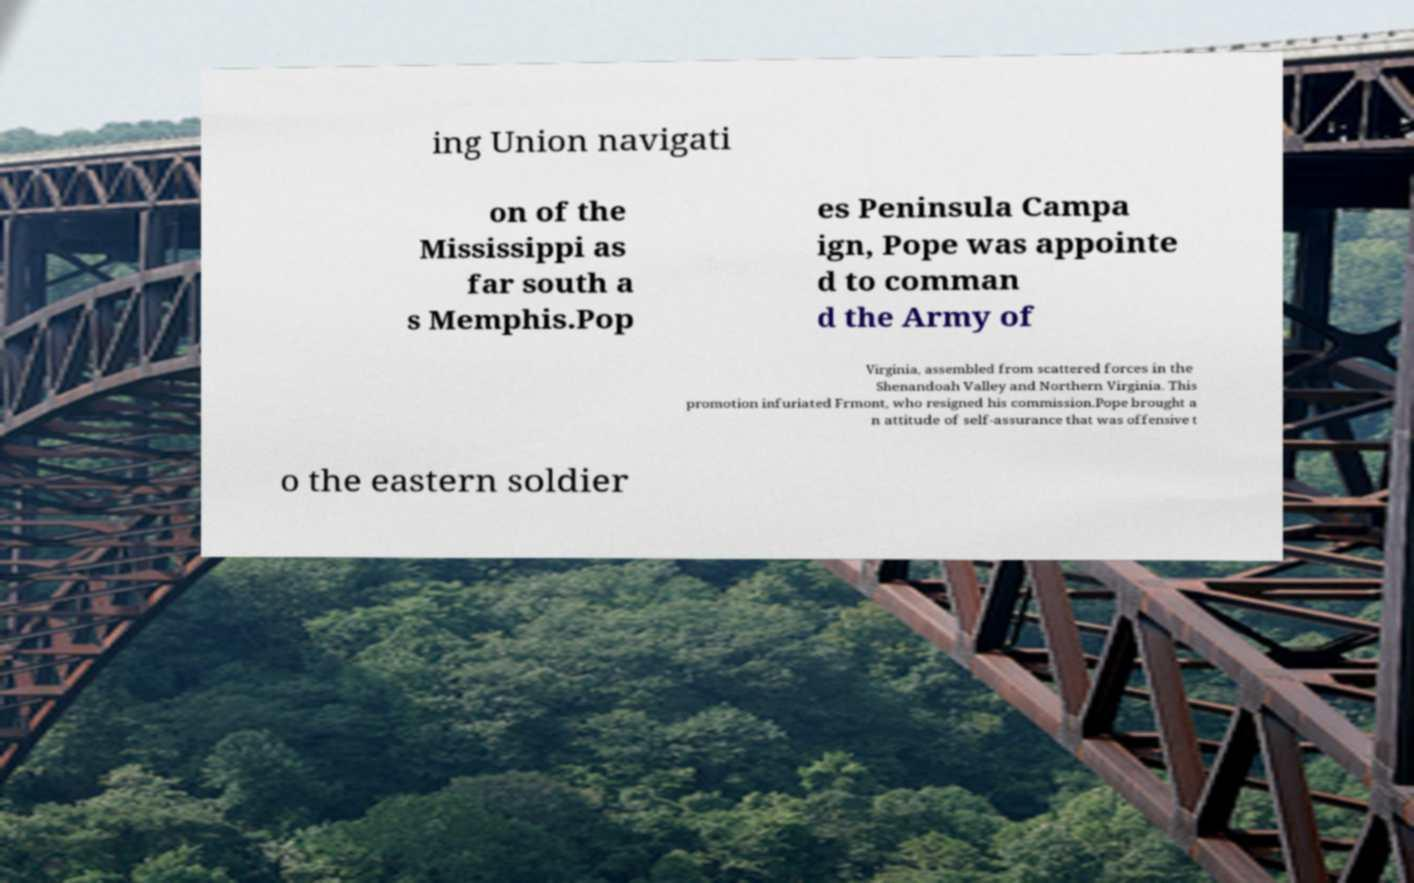What messages or text are displayed in this image? I need them in a readable, typed format. ing Union navigati on of the Mississippi as far south a s Memphis.Pop es Peninsula Campa ign, Pope was appointe d to comman d the Army of Virginia, assembled from scattered forces in the Shenandoah Valley and Northern Virginia. This promotion infuriated Frmont, who resigned his commission.Pope brought a n attitude of self-assurance that was offensive t o the eastern soldier 